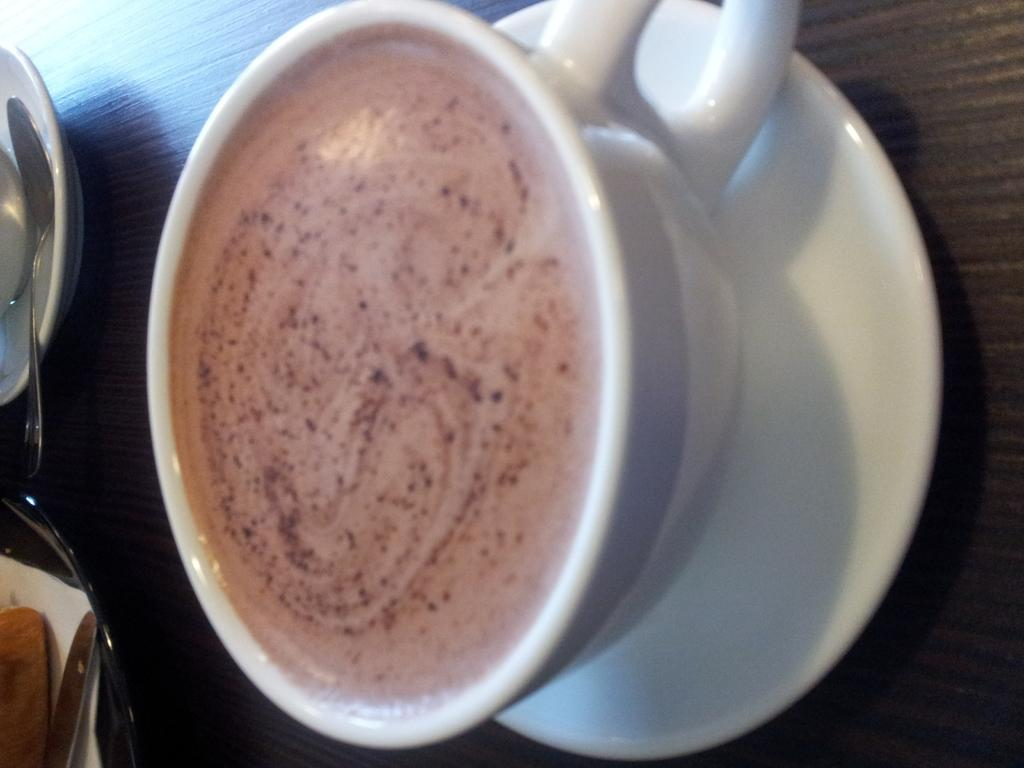What is the main object in the center of the image? There is a cup of tea in the center of the image. What utensil is present in the image? There is a spoon in the image. What accompanies the spoon in the image? There is a saucer in the image. Where are the spoon and saucer located in relation to the cup of tea? The spoon and saucer are on the left side of the image. On what surface are the cup, spoon, and saucer placed? The cup, spoon, and saucer are placed on a table. What type of juice is being served in the cup in the image? There is no juice present in the image; it is a cup of tea. What wish does the spoon grant when stirring the tea in the image? There is no indication in the image that the spoon has any magical properties or can grant wishes. 